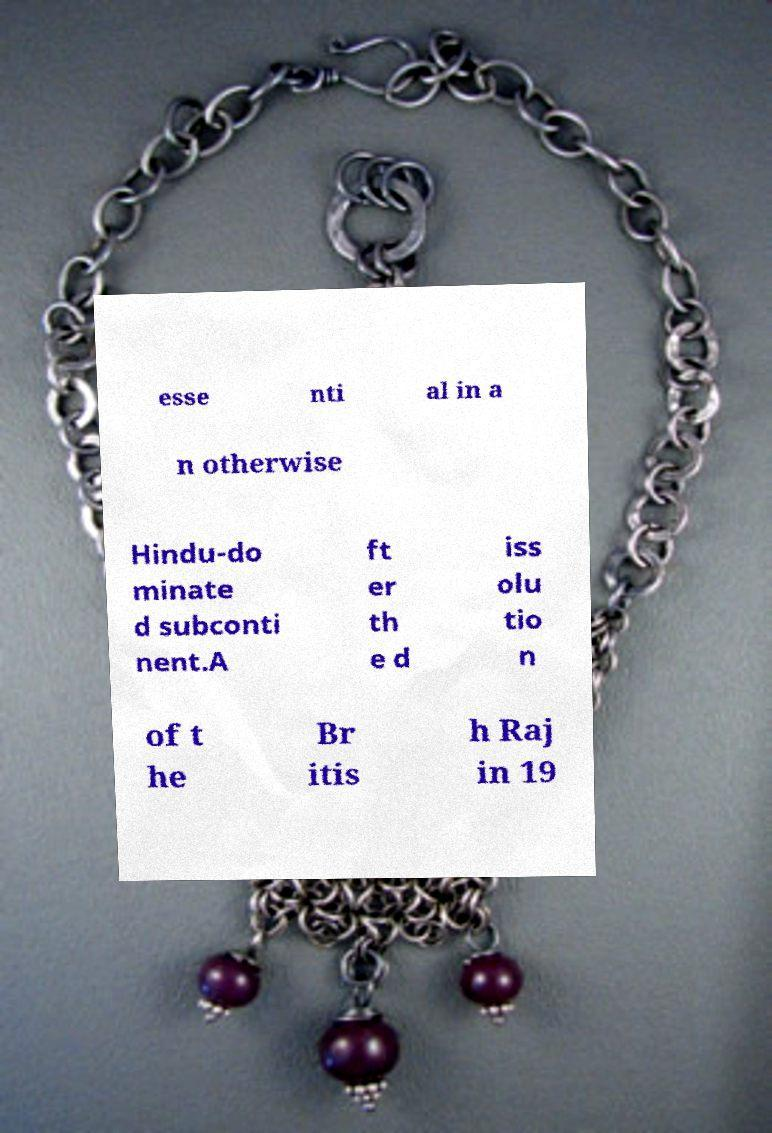What messages or text are displayed in this image? I need them in a readable, typed format. esse nti al in a n otherwise Hindu-do minate d subconti nent.A ft er th e d iss olu tio n of t he Br itis h Raj in 19 